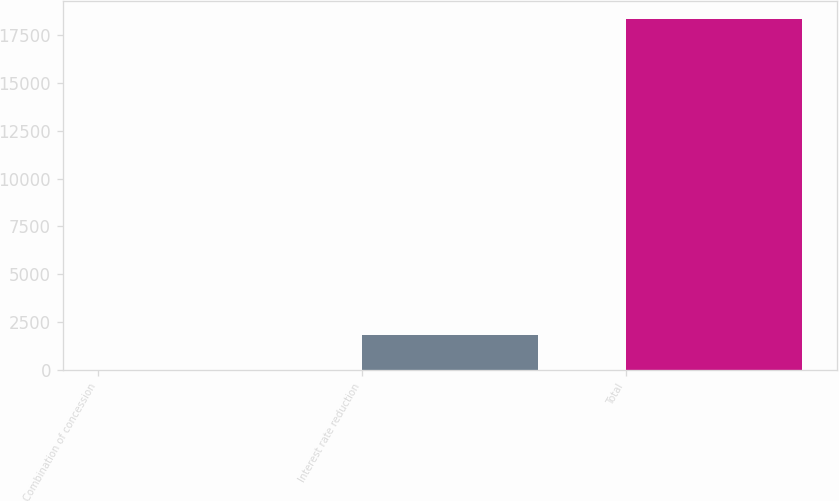Convert chart. <chart><loc_0><loc_0><loc_500><loc_500><bar_chart><fcel>Combination of concession<fcel>Interest rate reduction<fcel>Total<nl><fcel>3<fcel>1836<fcel>18333<nl></chart> 